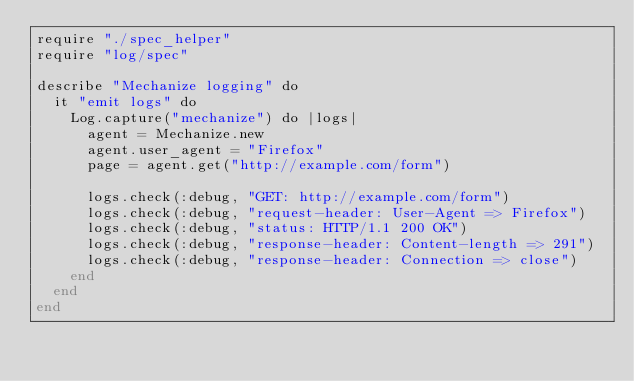<code> <loc_0><loc_0><loc_500><loc_500><_Crystal_>require "./spec_helper"
require "log/spec"

describe "Mechanize logging" do
  it "emit logs" do
    Log.capture("mechanize") do |logs|
      agent = Mechanize.new
      agent.user_agent = "Firefox"
      page = agent.get("http://example.com/form")

      logs.check(:debug, "GET: http://example.com/form")
      logs.check(:debug, "request-header: User-Agent => Firefox")
      logs.check(:debug, "status: HTTP/1.1 200 OK")
      logs.check(:debug, "response-header: Content-length => 291")
      logs.check(:debug, "response-header: Connection => close")
    end
  end
end
</code> 